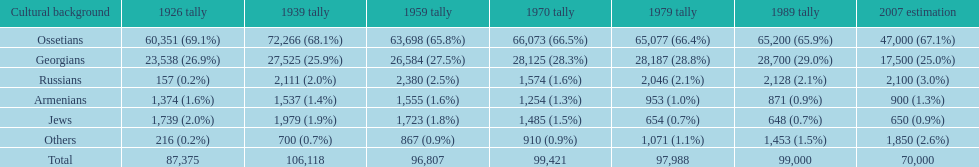How many ethnicities were below 1,000 people in 2007? 2. 